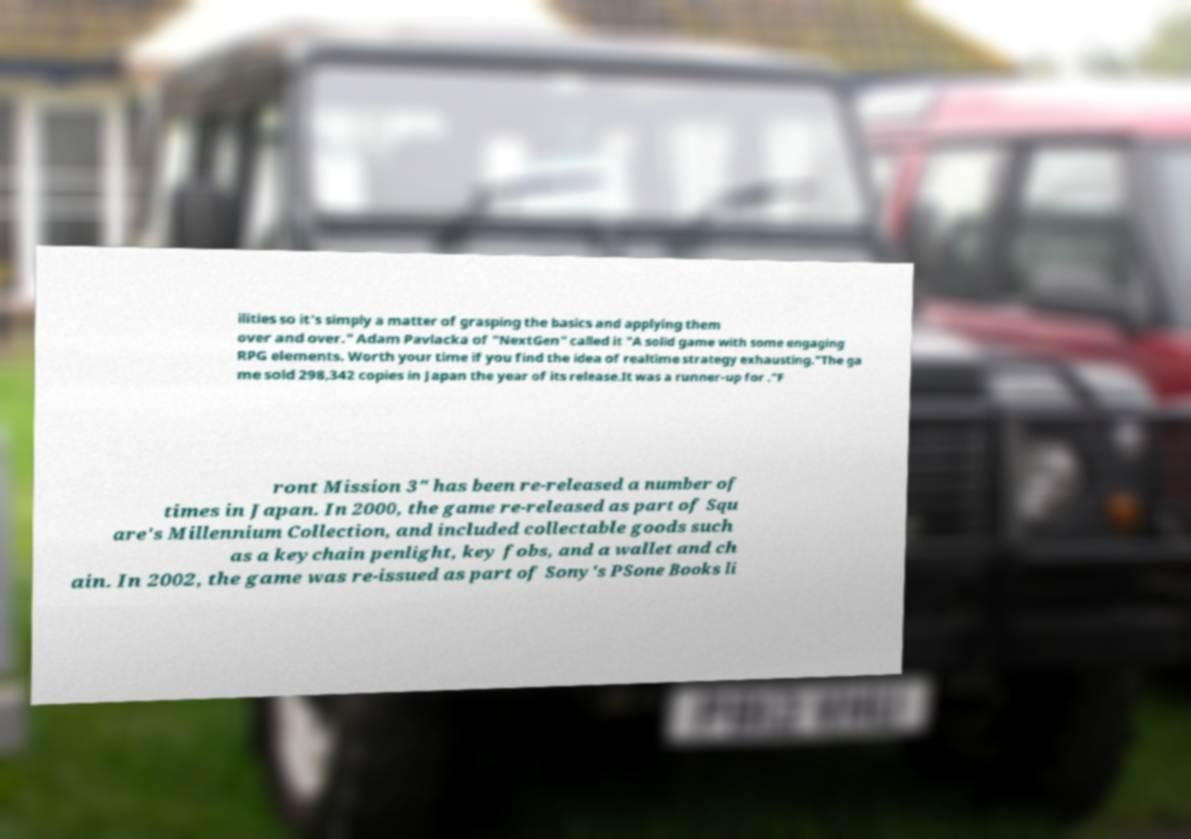For documentation purposes, I need the text within this image transcribed. Could you provide that? ilities so it's simply a matter of grasping the basics and applying them over and over." Adam Pavlacka of "NextGen" called it "A solid game with some engaging RPG elements. Worth your time if you find the idea of realtime strategy exhausting."The ga me sold 298,342 copies in Japan the year of its release.It was a runner-up for ."F ront Mission 3" has been re-released a number of times in Japan. In 2000, the game re-released as part of Squ are's Millennium Collection, and included collectable goods such as a keychain penlight, key fobs, and a wallet and ch ain. In 2002, the game was re-issued as part of Sony's PSone Books li 